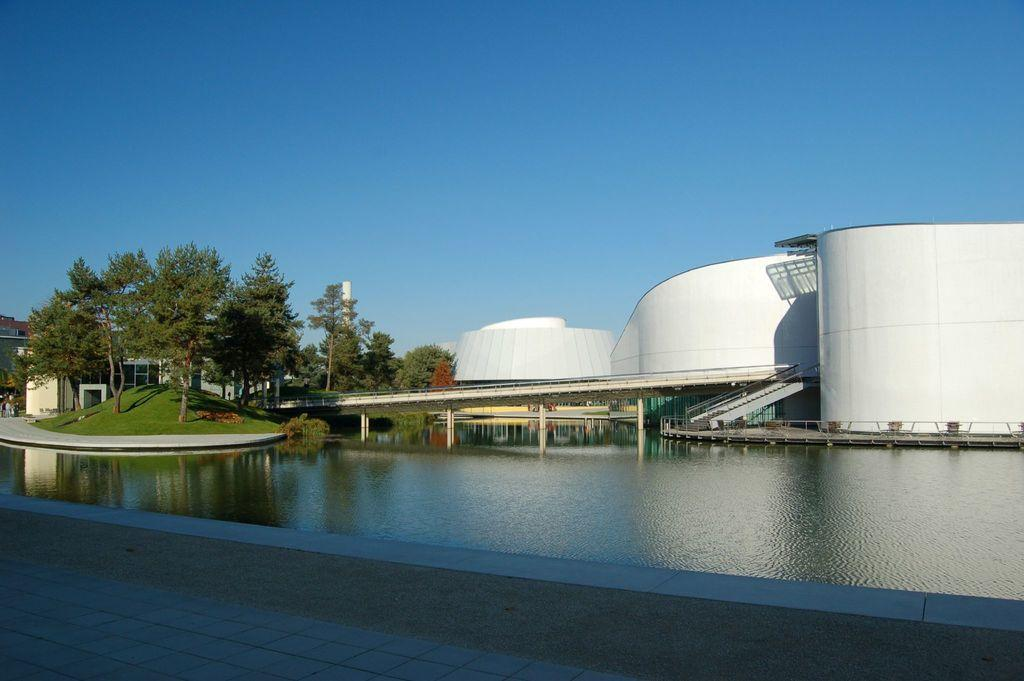What type of structures can be seen in the image? There are buildings in the image. What natural elements are present in the image? There are trees and water in the image. What man-made feature connects the two sides of the water? There is a bridge in the image. What else can be seen in the image besides the mentioned elements? There are other objects in the image. What is visible at the top of the image? The sky is visible at the top of the image. What is visible at the bottom of the image? The floor is visible at the bottom of the image. What type of pancake is being used as a decoration on the bridge in the image? There is no pancake present in the image, and the bridge is not being used as a decoration. What is the competition between the buildings in the image? There is no competition between the buildings in the image; they are simply structures in the scene. 